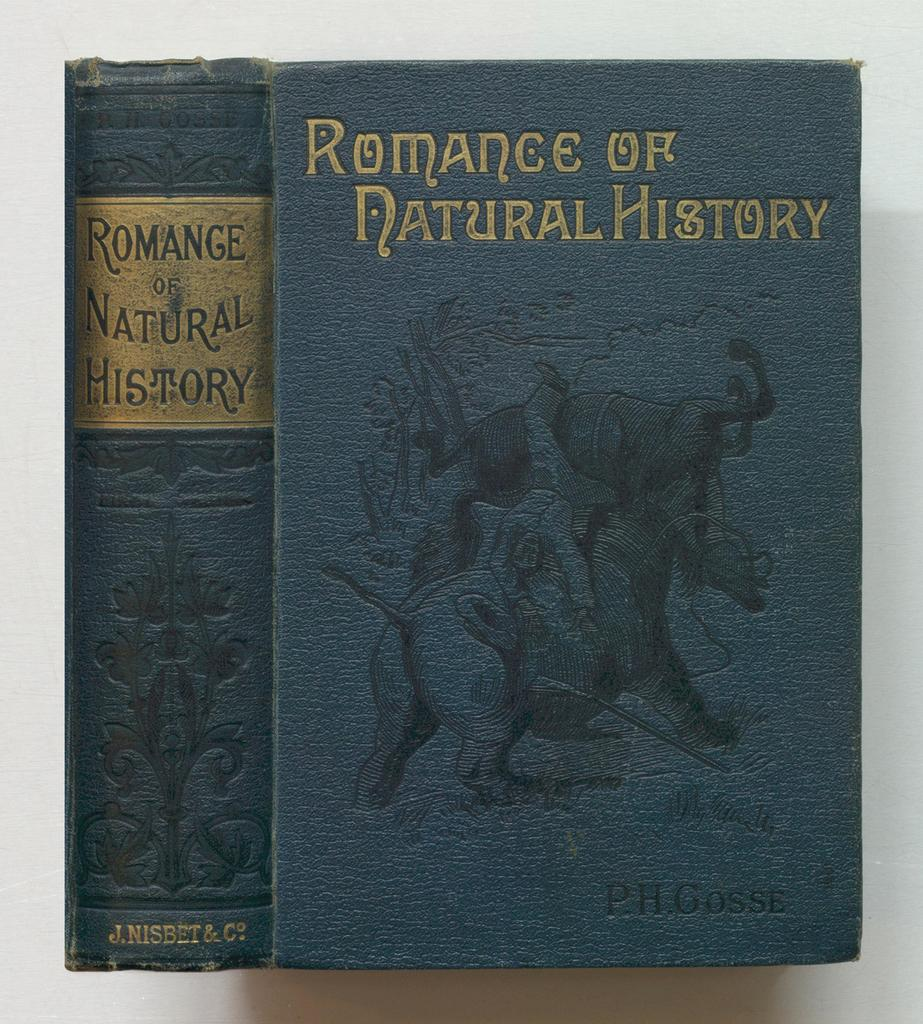Provide a one-sentence caption for the provided image. Two book volumes with the title Romance of Natural History. 